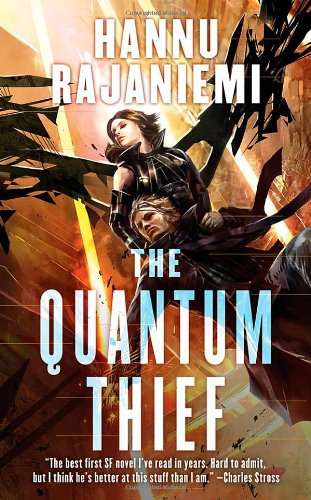What are the main themes explored in this book? The main themes in 'The Quantum Thief' include the exploration of memory, identity, and the nature of consciousness, all set within a complex and richly described post-singularity future. 